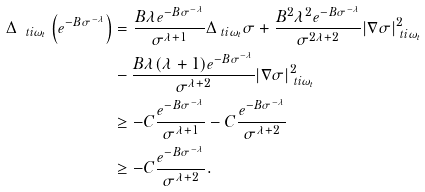<formula> <loc_0><loc_0><loc_500><loc_500>\Delta _ { \ t i { \omega } _ { t } } \left ( e ^ { - B \sigma ^ { - \lambda } } \right ) & = \frac { B \lambda e ^ { - B \sigma ^ { - \lambda } } } { \sigma ^ { \lambda + 1 } } \Delta _ { \ t i { \omega } _ { t } } \sigma + \frac { B ^ { 2 } \lambda ^ { 2 } e ^ { - B \sigma ^ { - \lambda } } } { \sigma ^ { 2 \lambda + 2 } } | \nabla \sigma | ^ { 2 } _ { \ t i { \omega } _ { t } } \\ & - \frac { B \lambda ( \lambda + 1 ) e ^ { - B \sigma ^ { - \lambda } } } { \sigma ^ { \lambda + 2 } } | \nabla \sigma | ^ { 2 } _ { \ t i { \omega } _ { t } } \\ & \geq - C \frac { e ^ { - B \sigma ^ { - \lambda } } } { \sigma ^ { \lambda + 1 } } - C \frac { e ^ { - B \sigma ^ { - \lambda } } } { \sigma ^ { \lambda + 2 } } \\ & \geq - C \frac { e ^ { - B \sigma ^ { - \lambda } } } { \sigma ^ { \lambda + 2 } } .</formula> 